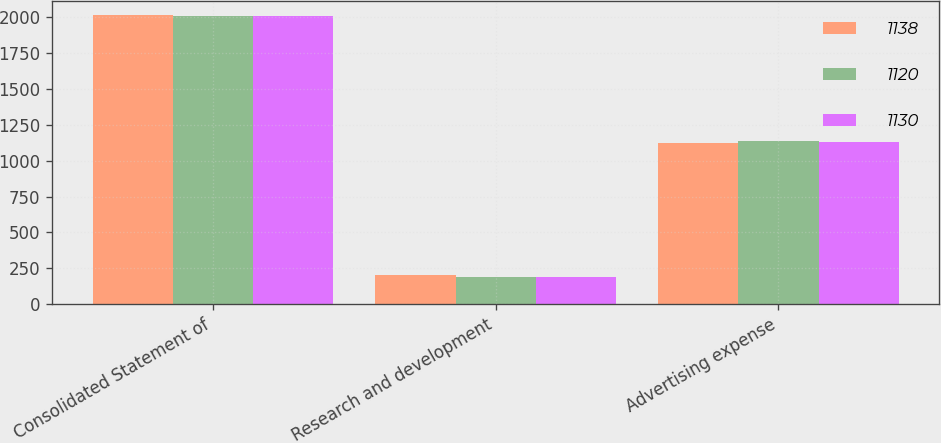Convert chart to OTSL. <chart><loc_0><loc_0><loc_500><loc_500><stacked_bar_chart><ecel><fcel>Consolidated Statement of<fcel>Research and development<fcel>Advertising expense<nl><fcel>1138<fcel>2012<fcel>206<fcel>1120<nl><fcel>1120<fcel>2011<fcel>192<fcel>1138<nl><fcel>1130<fcel>2010<fcel>187<fcel>1130<nl></chart> 